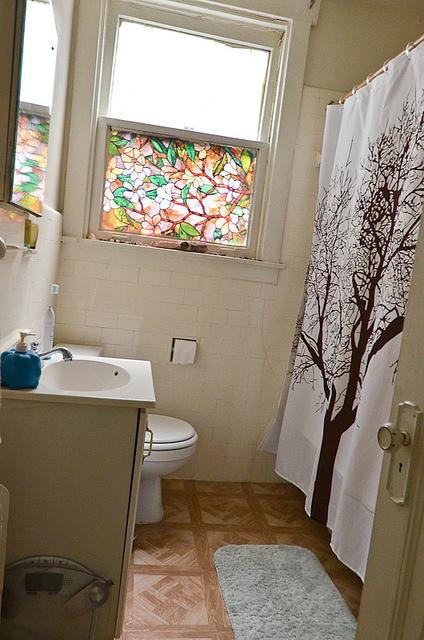Where is the tree at?
Answer briefly. Shower curtain. Is this a modern bathroom?
Short answer required. No. Is the door to this room shown in the picture?
Keep it brief. Yes. 